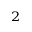Convert formula to latex. <formula><loc_0><loc_0><loc_500><loc_500>^ { 2 }</formula> 